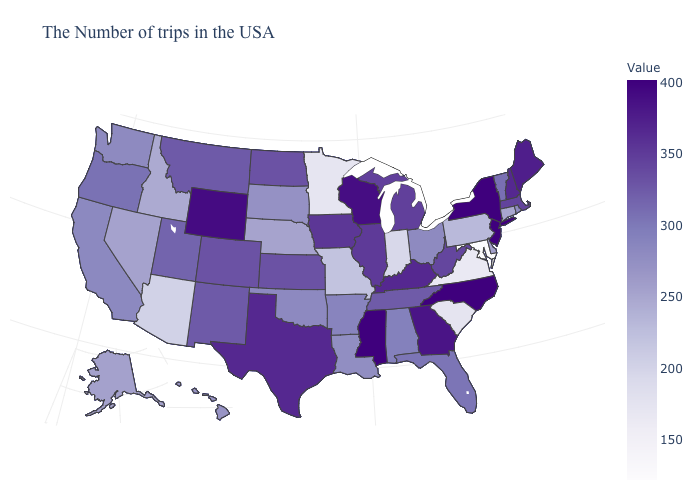Does Minnesota have the lowest value in the MidWest?
Concise answer only. Yes. Does West Virginia have a higher value than California?
Give a very brief answer. Yes. Does California have a lower value than West Virginia?
Be succinct. Yes. Which states hav the highest value in the Northeast?
Concise answer only. New York, New Jersey. 